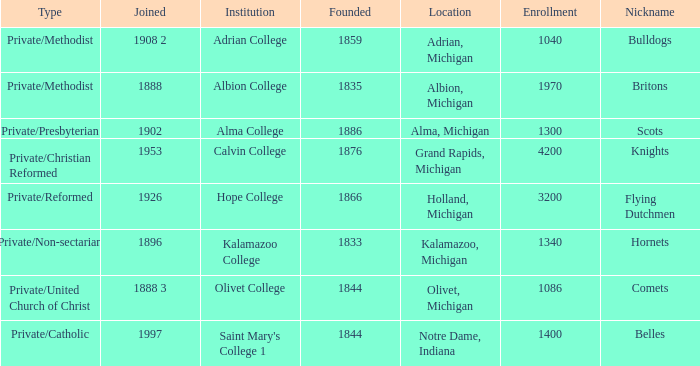Which categories fit under the institution calvin college? Private/Christian Reformed. 